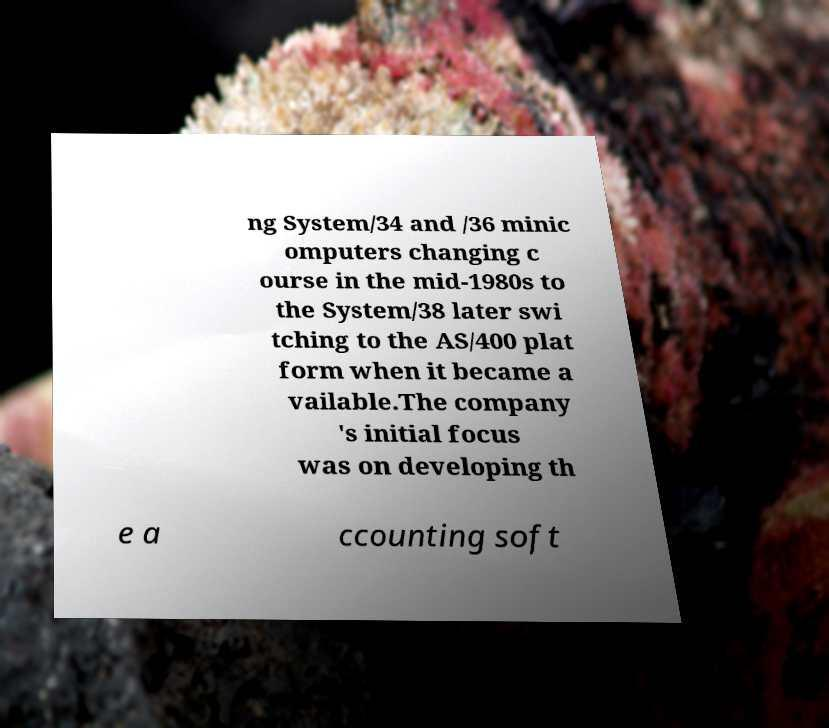Could you extract and type out the text from this image? ng System/34 and /36 minic omputers changing c ourse in the mid-1980s to the System/38 later swi tching to the AS/400 plat form when it became a vailable.The company 's initial focus was on developing th e a ccounting soft 